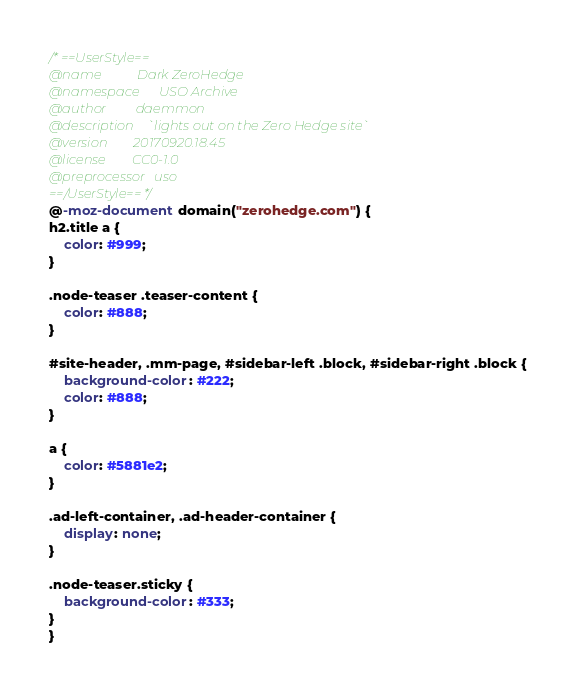Convert code to text. <code><loc_0><loc_0><loc_500><loc_500><_CSS_>/* ==UserStyle==
@name           Dark ZeroHedge
@namespace      USO Archive
@author         daemmon
@description    `lights out on the Zero Hedge site`
@version        20170920.18.45
@license        CC0-1.0
@preprocessor   uso
==/UserStyle== */
@-moz-document domain("zerohedge.com") {
h2.title a {
    color: #999;
}

.node-teaser .teaser-content {
    color: #888;
}

#site-header, .mm-page, #sidebar-left .block, #sidebar-right .block {
    background-color: #222;
    color: #888;
}

a {
    color: #5881e2;
}

.ad-left-container, .ad-header-container {
    display: none;
}

.node-teaser.sticky {
    background-color: #333;
}
}</code> 